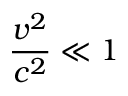Convert formula to latex. <formula><loc_0><loc_0><loc_500><loc_500>{ \frac { v ^ { 2 } } { c ^ { 2 } } } \ll 1</formula> 